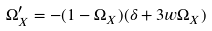<formula> <loc_0><loc_0><loc_500><loc_500>\Omega _ { X } ^ { \prime } = - ( 1 - \Omega _ { X } ) ( \delta + 3 w \Omega _ { X } )</formula> 